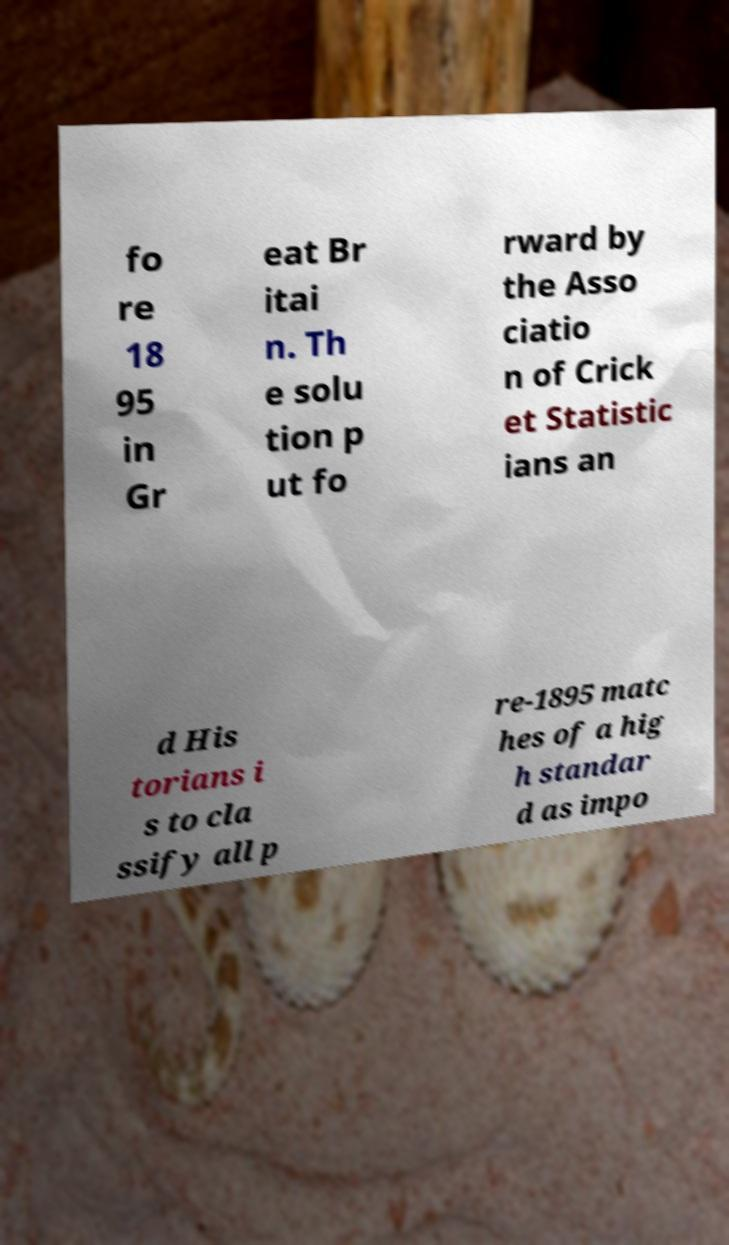For documentation purposes, I need the text within this image transcribed. Could you provide that? fo re 18 95 in Gr eat Br itai n. Th e solu tion p ut fo rward by the Asso ciatio n of Crick et Statistic ians an d His torians i s to cla ssify all p re-1895 matc hes of a hig h standar d as impo 